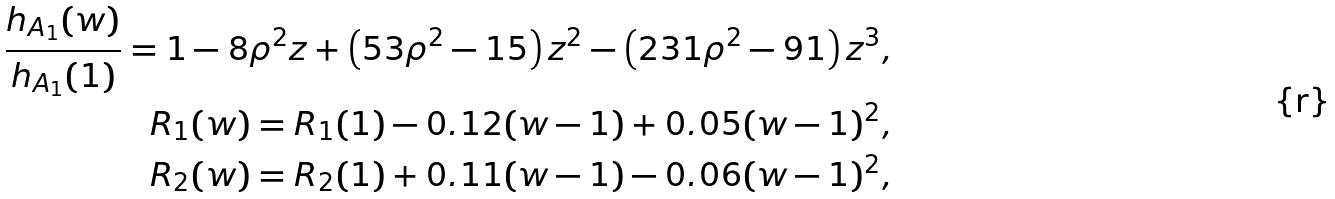Convert formula to latex. <formula><loc_0><loc_0><loc_500><loc_500>\frac { h _ { A _ { 1 } } ( w ) } { h _ { A _ { 1 } } ( 1 ) } = 1 - 8 \rho ^ { 2 } z + \left ( 5 3 \rho ^ { 2 } - 1 5 \right ) z ^ { 2 } - \left ( 2 3 1 \rho ^ { 2 } - 9 1 \right ) z ^ { 3 } , \\ R _ { 1 } ( w ) = R _ { 1 } ( 1 ) - 0 . 1 2 ( w - 1 ) + 0 . 0 5 ( w - 1 ) ^ { 2 } , \\ R _ { 2 } ( w ) = R _ { 2 } ( 1 ) + 0 . 1 1 ( w - 1 ) - 0 . 0 6 ( w - 1 ) ^ { 2 } ,</formula> 